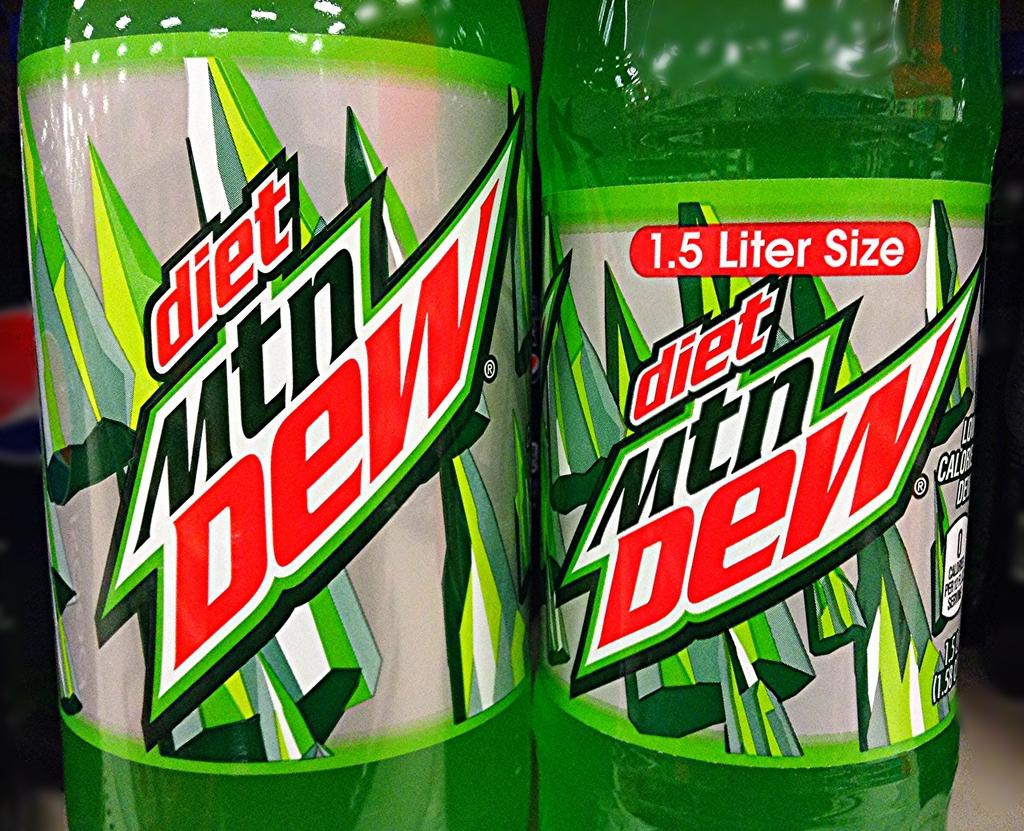<image>
Create a compact narrative representing the image presented. The bottle to the right is 1.5 Liter Size of diet Mtn Dew. 